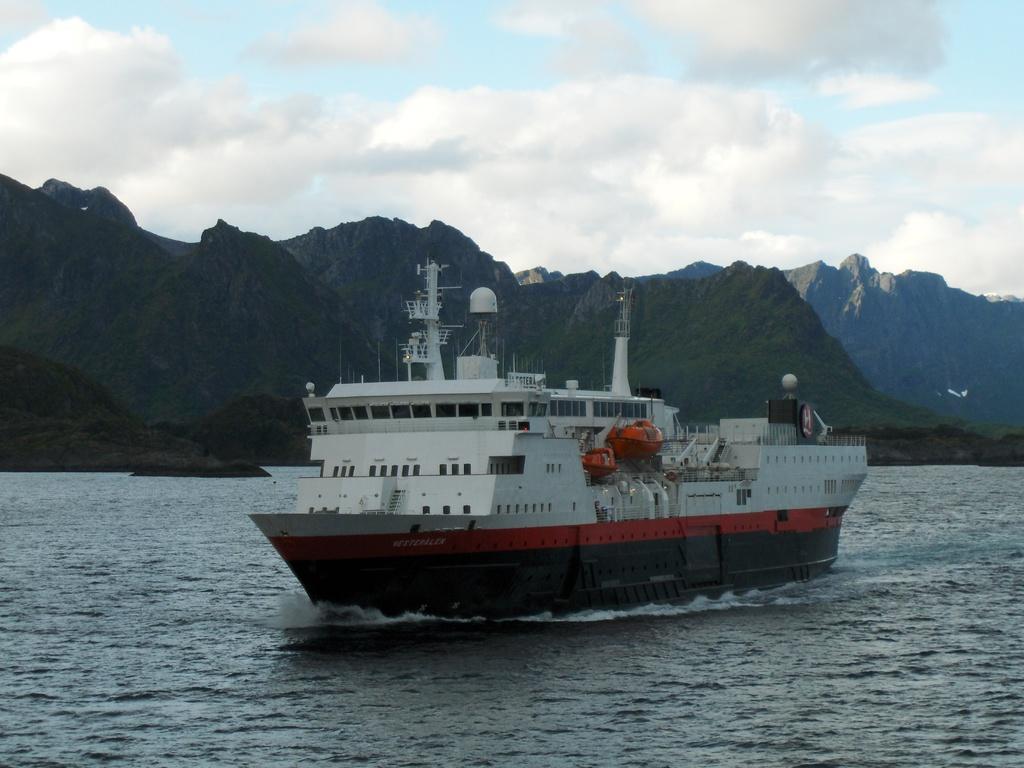Describe this image in one or two sentences. In this image there is a ship on the river, in the background there are mountains and the sky. 